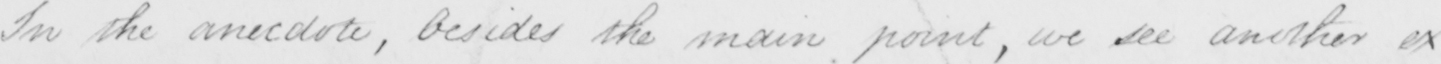Can you tell me what this handwritten text says? In the anecdote , besides the main point , we see another ex- 